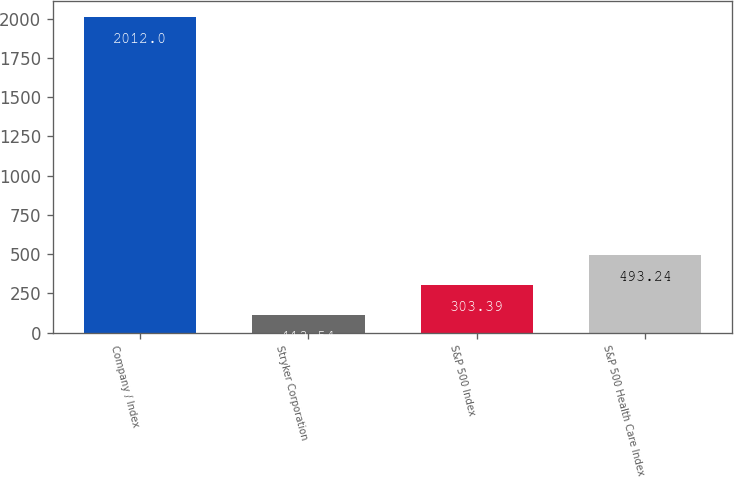Convert chart to OTSL. <chart><loc_0><loc_0><loc_500><loc_500><bar_chart><fcel>Company / Index<fcel>Stryker Corporation<fcel>S&P 500 Index<fcel>S&P 500 Health Care Index<nl><fcel>2012<fcel>113.54<fcel>303.39<fcel>493.24<nl></chart> 